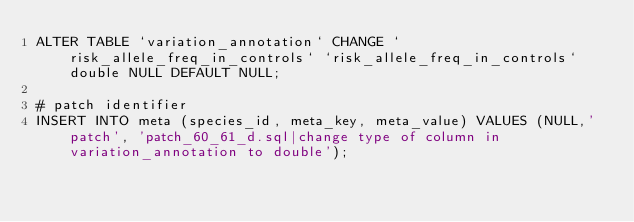<code> <loc_0><loc_0><loc_500><loc_500><_SQL_>ALTER TABLE `variation_annotation` CHANGE `risk_allele_freq_in_controls` `risk_allele_freq_in_controls` double NULL DEFAULT NULL;

# patch identifier
INSERT INTO meta (species_id, meta_key, meta_value) VALUES (NULL,'patch', 'patch_60_61_d.sql|change type of column in variation_annotation to double');
</code> 